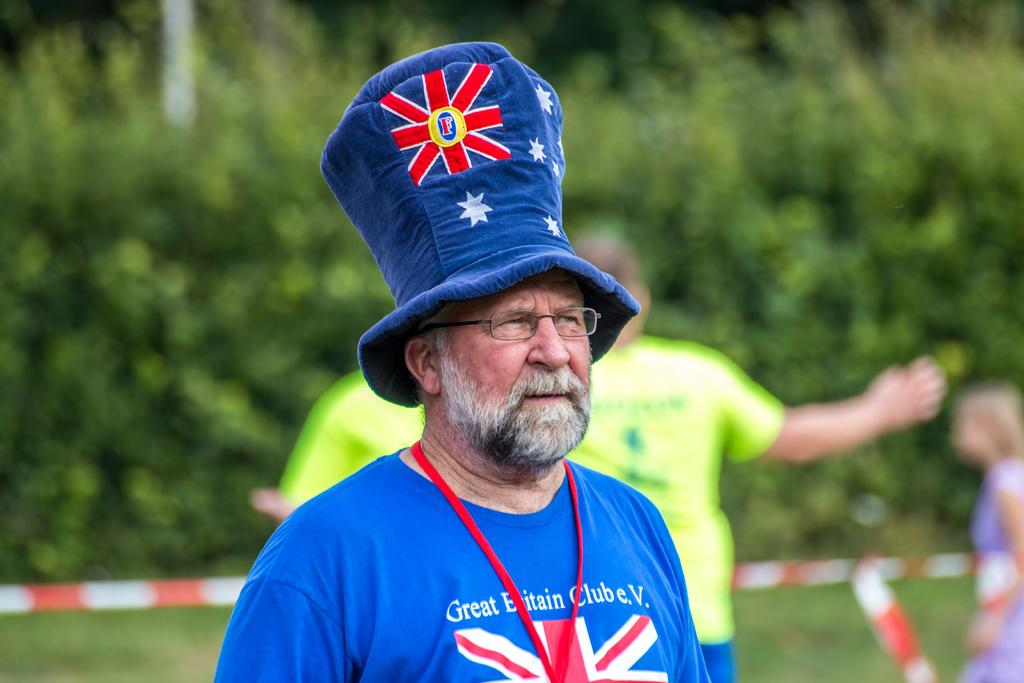<image>
Describe the image concisely. A man wearing a Club Britain e.V. shirt and a big blue hat stands in an athletic field. 